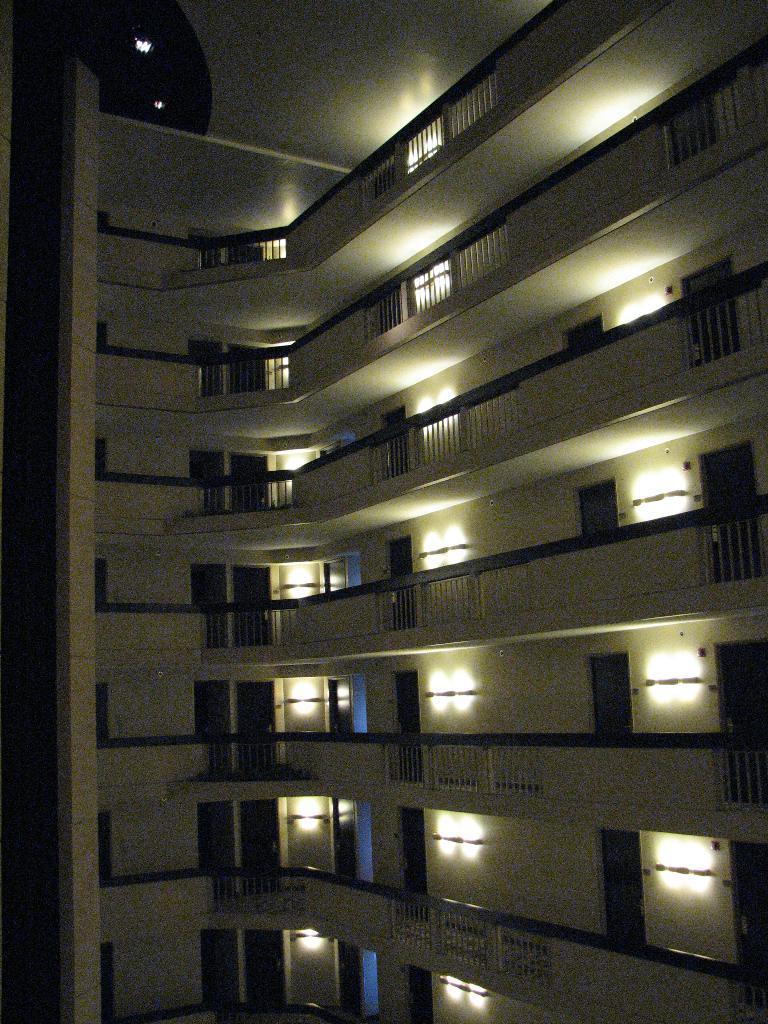Could you give a brief overview of what you see in this image? In this image I can see the building. To the building I can see the railing and many lights to the wall. I can also see the doors to the building. 